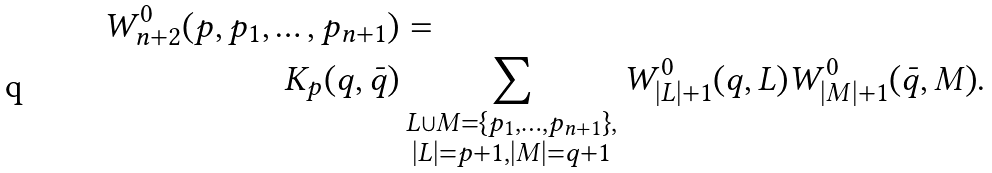<formula> <loc_0><loc_0><loc_500><loc_500>W _ { n + 2 } ^ { 0 } ( p , p _ { 1 } , \dots , p _ { n + 1 } ) & = \\ K _ { p } ( q , \bar { q } ) & \sum _ { \substack { L \cup M = \{ p _ { 1 } , \dots , p _ { n + 1 } \} , \\ | L | = p + 1 , | M | = q + 1 } } W ^ { 0 } _ { | L | + 1 } ( q , L ) W ^ { 0 } _ { | M | + 1 } ( \bar { q } , M ) .</formula> 